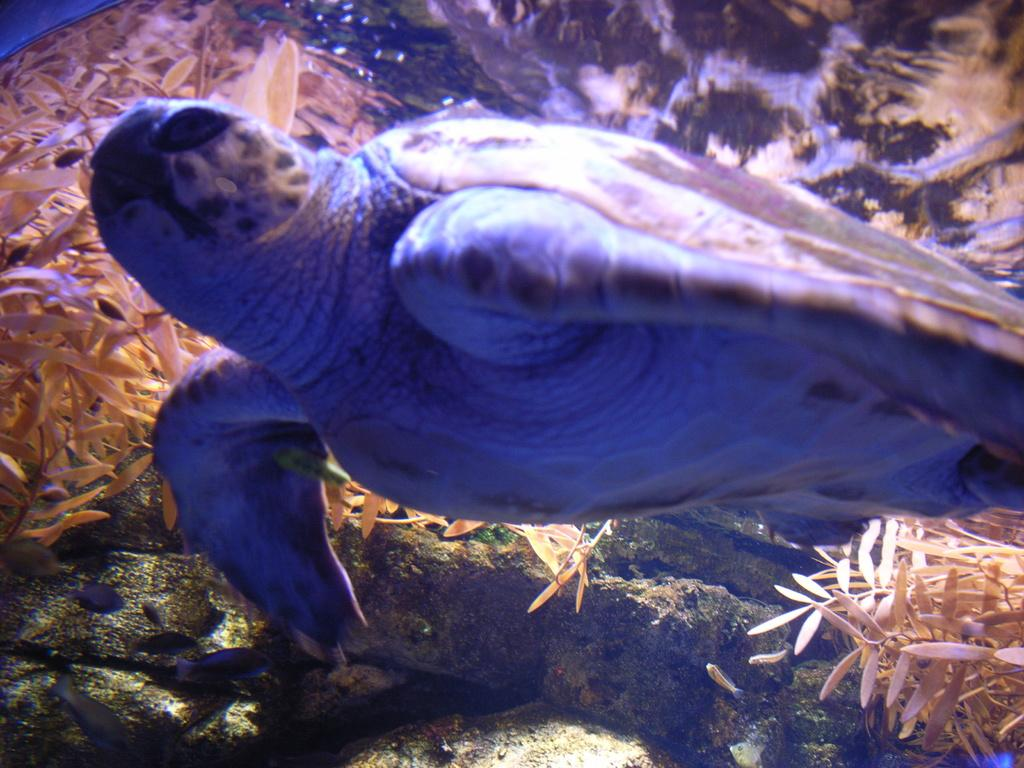What animal is present in the image? There is a turtle in the image. Where is the turtle located? The turtle is underwater. What type of vegetation can be seen in the image? There are aquatic plants in the image. What type of fruit can be seen floating near the turtle in the image? There is no fruit present in the image; it features a turtle underwater with aquatic plants. 